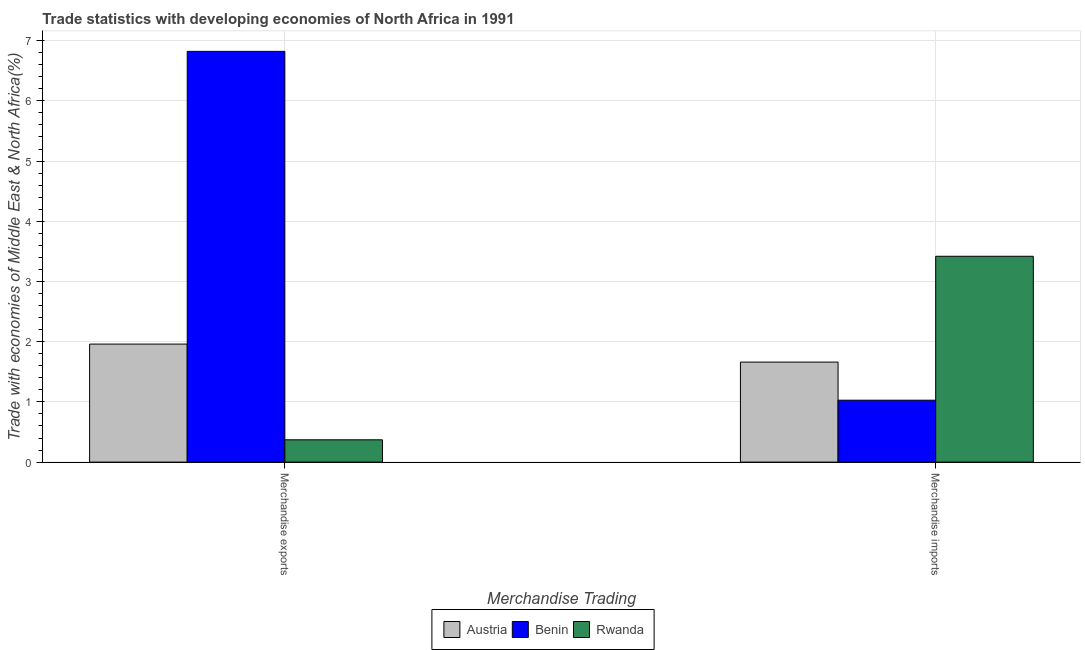How many different coloured bars are there?
Make the answer very short. 3. How many groups of bars are there?
Your answer should be very brief. 2. Are the number of bars on each tick of the X-axis equal?
Provide a short and direct response. Yes. How many bars are there on the 2nd tick from the left?
Provide a succinct answer. 3. What is the label of the 1st group of bars from the left?
Keep it short and to the point. Merchandise exports. What is the merchandise imports in Benin?
Keep it short and to the point. 1.03. Across all countries, what is the maximum merchandise imports?
Ensure brevity in your answer.  3.42. Across all countries, what is the minimum merchandise imports?
Offer a very short reply. 1.03. In which country was the merchandise exports maximum?
Provide a succinct answer. Benin. In which country was the merchandise imports minimum?
Your answer should be very brief. Benin. What is the total merchandise exports in the graph?
Your answer should be compact. 9.15. What is the difference between the merchandise exports in Austria and that in Rwanda?
Keep it short and to the point. 1.59. What is the difference between the merchandise imports in Austria and the merchandise exports in Benin?
Offer a terse response. -5.16. What is the average merchandise imports per country?
Provide a short and direct response. 2.04. What is the difference between the merchandise exports and merchandise imports in Benin?
Your answer should be very brief. 5.79. In how many countries, is the merchandise exports greater than 3 %?
Offer a terse response. 1. What is the ratio of the merchandise exports in Benin to that in Austria?
Provide a short and direct response. 3.48. Is the merchandise imports in Rwanda less than that in Benin?
Ensure brevity in your answer.  No. What does the 2nd bar from the left in Merchandise exports represents?
Give a very brief answer. Benin. What does the 2nd bar from the right in Merchandise imports represents?
Your response must be concise. Benin. How many bars are there?
Your answer should be very brief. 6. Are all the bars in the graph horizontal?
Keep it short and to the point. No. What is the difference between two consecutive major ticks on the Y-axis?
Your response must be concise. 1. Are the values on the major ticks of Y-axis written in scientific E-notation?
Give a very brief answer. No. Does the graph contain any zero values?
Your answer should be very brief. No. Does the graph contain grids?
Your response must be concise. Yes. Where does the legend appear in the graph?
Provide a short and direct response. Bottom center. How are the legend labels stacked?
Make the answer very short. Horizontal. What is the title of the graph?
Your response must be concise. Trade statistics with developing economies of North Africa in 1991. Does "Pacific island small states" appear as one of the legend labels in the graph?
Ensure brevity in your answer.  No. What is the label or title of the X-axis?
Offer a terse response. Merchandise Trading. What is the label or title of the Y-axis?
Your response must be concise. Trade with economies of Middle East & North Africa(%). What is the Trade with economies of Middle East & North Africa(%) of Austria in Merchandise exports?
Provide a short and direct response. 1.96. What is the Trade with economies of Middle East & North Africa(%) of Benin in Merchandise exports?
Your response must be concise. 6.82. What is the Trade with economies of Middle East & North Africa(%) of Rwanda in Merchandise exports?
Your answer should be very brief. 0.37. What is the Trade with economies of Middle East & North Africa(%) in Austria in Merchandise imports?
Keep it short and to the point. 1.66. What is the Trade with economies of Middle East & North Africa(%) of Benin in Merchandise imports?
Provide a succinct answer. 1.03. What is the Trade with economies of Middle East & North Africa(%) of Rwanda in Merchandise imports?
Offer a terse response. 3.42. Across all Merchandise Trading, what is the maximum Trade with economies of Middle East & North Africa(%) of Austria?
Provide a short and direct response. 1.96. Across all Merchandise Trading, what is the maximum Trade with economies of Middle East & North Africa(%) in Benin?
Offer a very short reply. 6.82. Across all Merchandise Trading, what is the maximum Trade with economies of Middle East & North Africa(%) of Rwanda?
Your response must be concise. 3.42. Across all Merchandise Trading, what is the minimum Trade with economies of Middle East & North Africa(%) of Austria?
Your answer should be very brief. 1.66. Across all Merchandise Trading, what is the minimum Trade with economies of Middle East & North Africa(%) in Benin?
Provide a succinct answer. 1.03. Across all Merchandise Trading, what is the minimum Trade with economies of Middle East & North Africa(%) in Rwanda?
Offer a very short reply. 0.37. What is the total Trade with economies of Middle East & North Africa(%) of Austria in the graph?
Your response must be concise. 3.62. What is the total Trade with economies of Middle East & North Africa(%) of Benin in the graph?
Provide a short and direct response. 7.85. What is the total Trade with economies of Middle East & North Africa(%) in Rwanda in the graph?
Offer a terse response. 3.79. What is the difference between the Trade with economies of Middle East & North Africa(%) in Austria in Merchandise exports and that in Merchandise imports?
Provide a short and direct response. 0.3. What is the difference between the Trade with economies of Middle East & North Africa(%) of Benin in Merchandise exports and that in Merchandise imports?
Make the answer very short. 5.79. What is the difference between the Trade with economies of Middle East & North Africa(%) of Rwanda in Merchandise exports and that in Merchandise imports?
Your response must be concise. -3.05. What is the difference between the Trade with economies of Middle East & North Africa(%) of Austria in Merchandise exports and the Trade with economies of Middle East & North Africa(%) of Benin in Merchandise imports?
Offer a terse response. 0.93. What is the difference between the Trade with economies of Middle East & North Africa(%) of Austria in Merchandise exports and the Trade with economies of Middle East & North Africa(%) of Rwanda in Merchandise imports?
Provide a succinct answer. -1.46. What is the difference between the Trade with economies of Middle East & North Africa(%) in Benin in Merchandise exports and the Trade with economies of Middle East & North Africa(%) in Rwanda in Merchandise imports?
Provide a short and direct response. 3.4. What is the average Trade with economies of Middle East & North Africa(%) in Austria per Merchandise Trading?
Provide a short and direct response. 1.81. What is the average Trade with economies of Middle East & North Africa(%) of Benin per Merchandise Trading?
Provide a succinct answer. 3.93. What is the average Trade with economies of Middle East & North Africa(%) in Rwanda per Merchandise Trading?
Make the answer very short. 1.89. What is the difference between the Trade with economies of Middle East & North Africa(%) in Austria and Trade with economies of Middle East & North Africa(%) in Benin in Merchandise exports?
Make the answer very short. -4.86. What is the difference between the Trade with economies of Middle East & North Africa(%) of Austria and Trade with economies of Middle East & North Africa(%) of Rwanda in Merchandise exports?
Your response must be concise. 1.59. What is the difference between the Trade with economies of Middle East & North Africa(%) of Benin and Trade with economies of Middle East & North Africa(%) of Rwanda in Merchandise exports?
Your answer should be very brief. 6.45. What is the difference between the Trade with economies of Middle East & North Africa(%) in Austria and Trade with economies of Middle East & North Africa(%) in Benin in Merchandise imports?
Offer a very short reply. 0.63. What is the difference between the Trade with economies of Middle East & North Africa(%) of Austria and Trade with economies of Middle East & North Africa(%) of Rwanda in Merchandise imports?
Make the answer very short. -1.76. What is the difference between the Trade with economies of Middle East & North Africa(%) of Benin and Trade with economies of Middle East & North Africa(%) of Rwanda in Merchandise imports?
Your answer should be compact. -2.39. What is the ratio of the Trade with economies of Middle East & North Africa(%) in Austria in Merchandise exports to that in Merchandise imports?
Make the answer very short. 1.18. What is the ratio of the Trade with economies of Middle East & North Africa(%) in Benin in Merchandise exports to that in Merchandise imports?
Your response must be concise. 6.63. What is the ratio of the Trade with economies of Middle East & North Africa(%) of Rwanda in Merchandise exports to that in Merchandise imports?
Give a very brief answer. 0.11. What is the difference between the highest and the second highest Trade with economies of Middle East & North Africa(%) in Austria?
Make the answer very short. 0.3. What is the difference between the highest and the second highest Trade with economies of Middle East & North Africa(%) in Benin?
Your answer should be very brief. 5.79. What is the difference between the highest and the second highest Trade with economies of Middle East & North Africa(%) in Rwanda?
Offer a terse response. 3.05. What is the difference between the highest and the lowest Trade with economies of Middle East & North Africa(%) of Austria?
Provide a short and direct response. 0.3. What is the difference between the highest and the lowest Trade with economies of Middle East & North Africa(%) in Benin?
Your answer should be very brief. 5.79. What is the difference between the highest and the lowest Trade with economies of Middle East & North Africa(%) in Rwanda?
Your response must be concise. 3.05. 